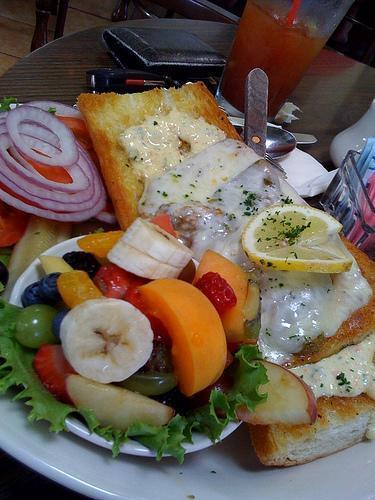Does the description: "The banana is at the left side of the sandwich." accurately reflect the image?
Answer yes or no. Yes. Does the image validate the caption "The sandwich is touching the dining table."?
Answer yes or no. No. 